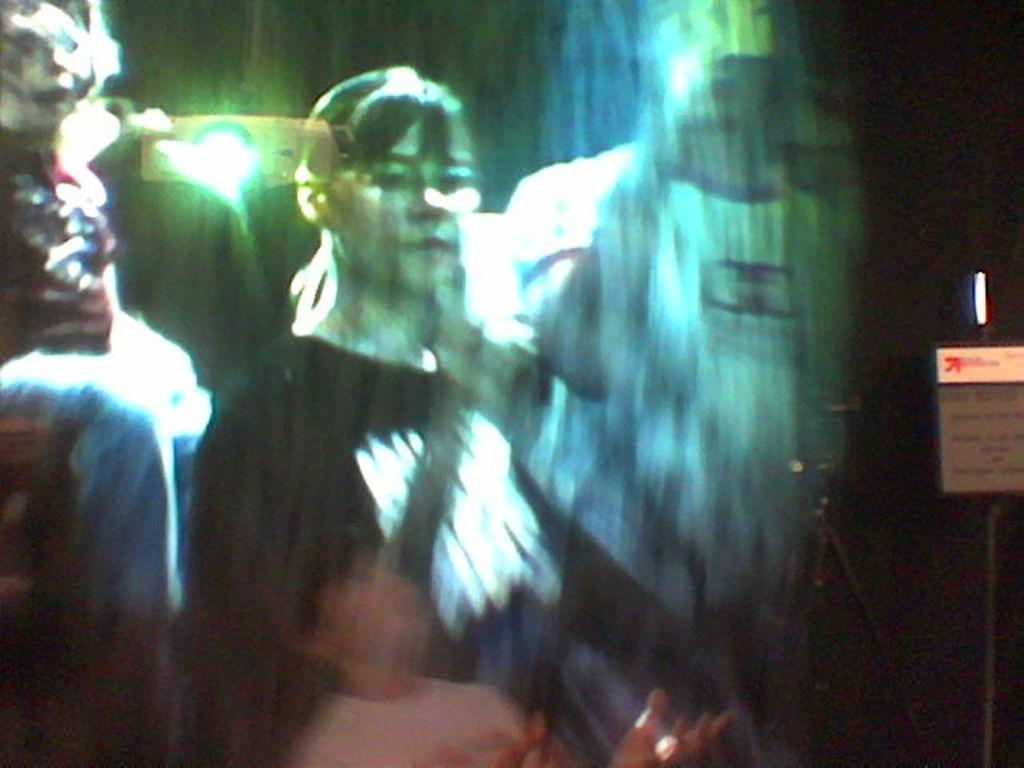What is the overall quality of the image? The image is blurry. Can you identify any individuals in the image? Yes, there is a woman in the image. Are there any other people present in the image? Yes, there are other people in the image. What is located on the right side of the image? There is a board on the right side of the image. What can be seen in the background of the image? There is a light visible in the background of the image. What type of vegetable is being used as a prop in the image? There is no vegetable present in the image. Can you tell me how many playgrounds are visible in the image? There are no playgrounds visible in the image. 